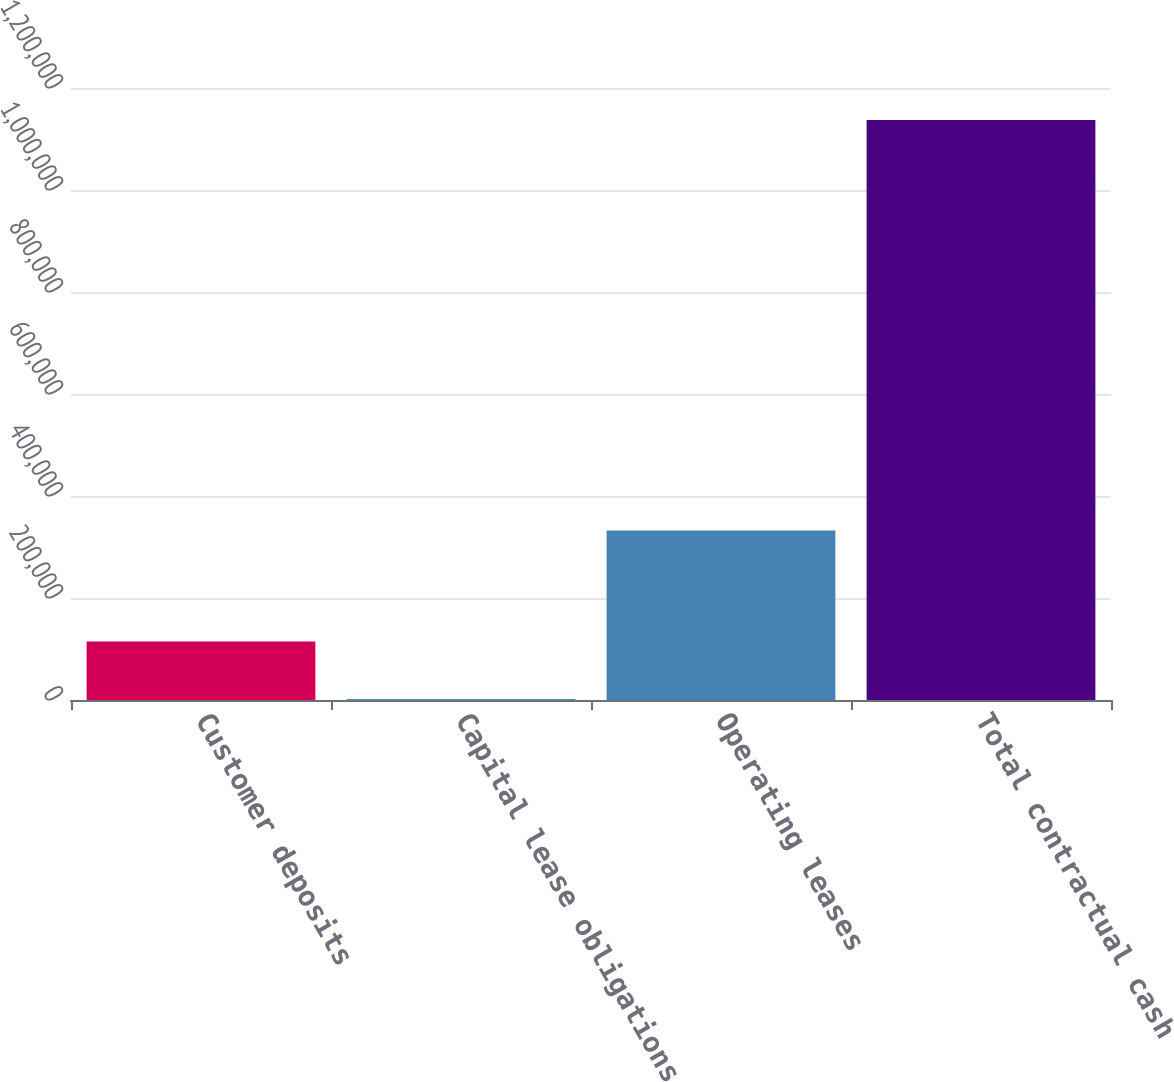Convert chart to OTSL. <chart><loc_0><loc_0><loc_500><loc_500><bar_chart><fcel>Customer deposits<fcel>Capital lease obligations<fcel>Operating leases<fcel>Total contractual cash<nl><fcel>114872<fcel>1293<fcel>332119<fcel>1.13708e+06<nl></chart> 